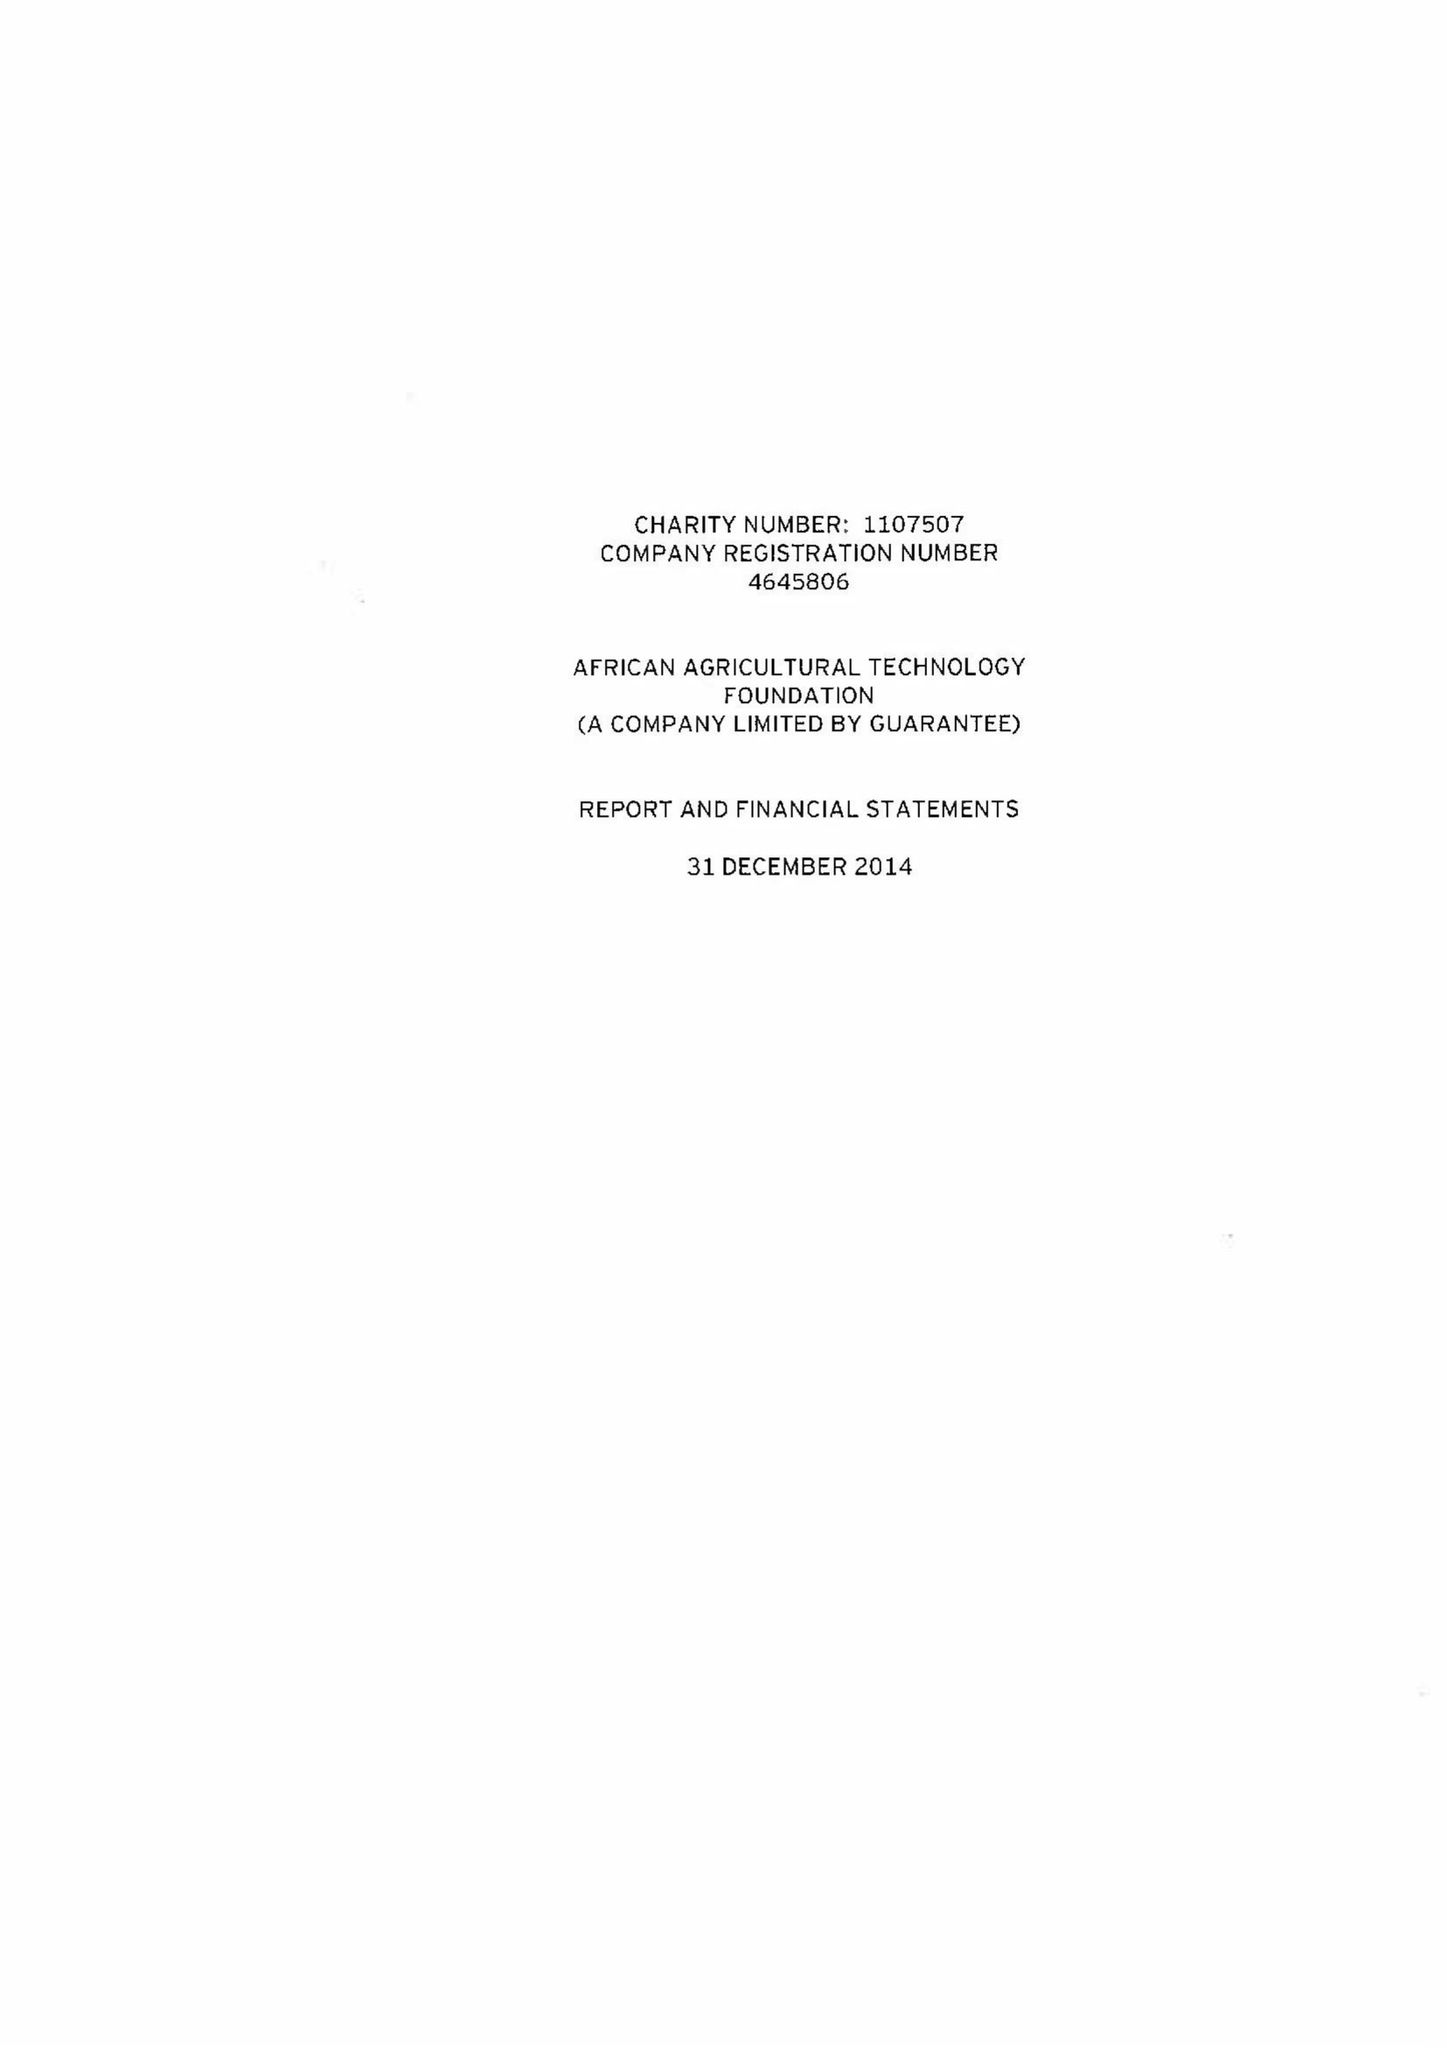What is the value for the charity_name?
Answer the question using a single word or phrase. African Agricultural Technology Foundation 